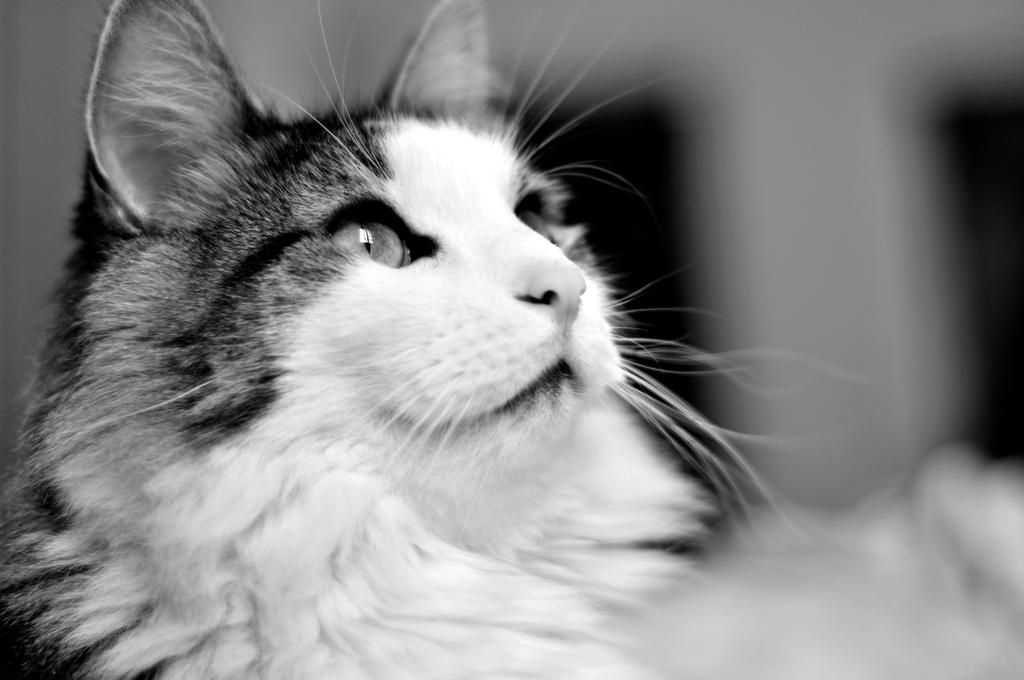What is the color scheme of the image? The image is black and white. What is the main subject of the image? There is a cat in the center of the image. Can you describe the background of the image? The background of the image is blurred. What type of cushion is the cat sitting on in the image? There is no cushion present in the image; the cat is in the center of the black and white image with a blurred background. 